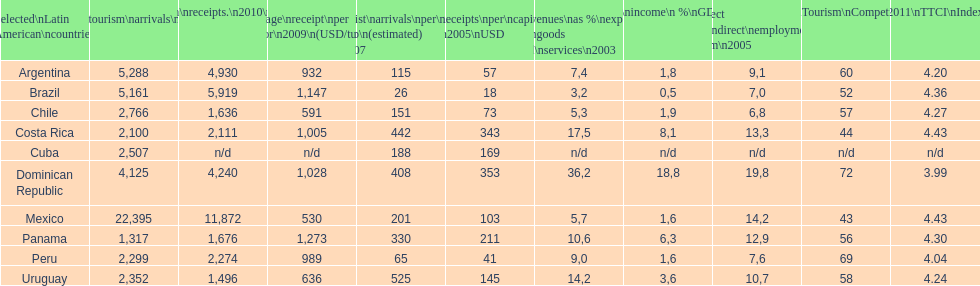In the year 2010, which country was the top destination for international tourists? Mexico. 